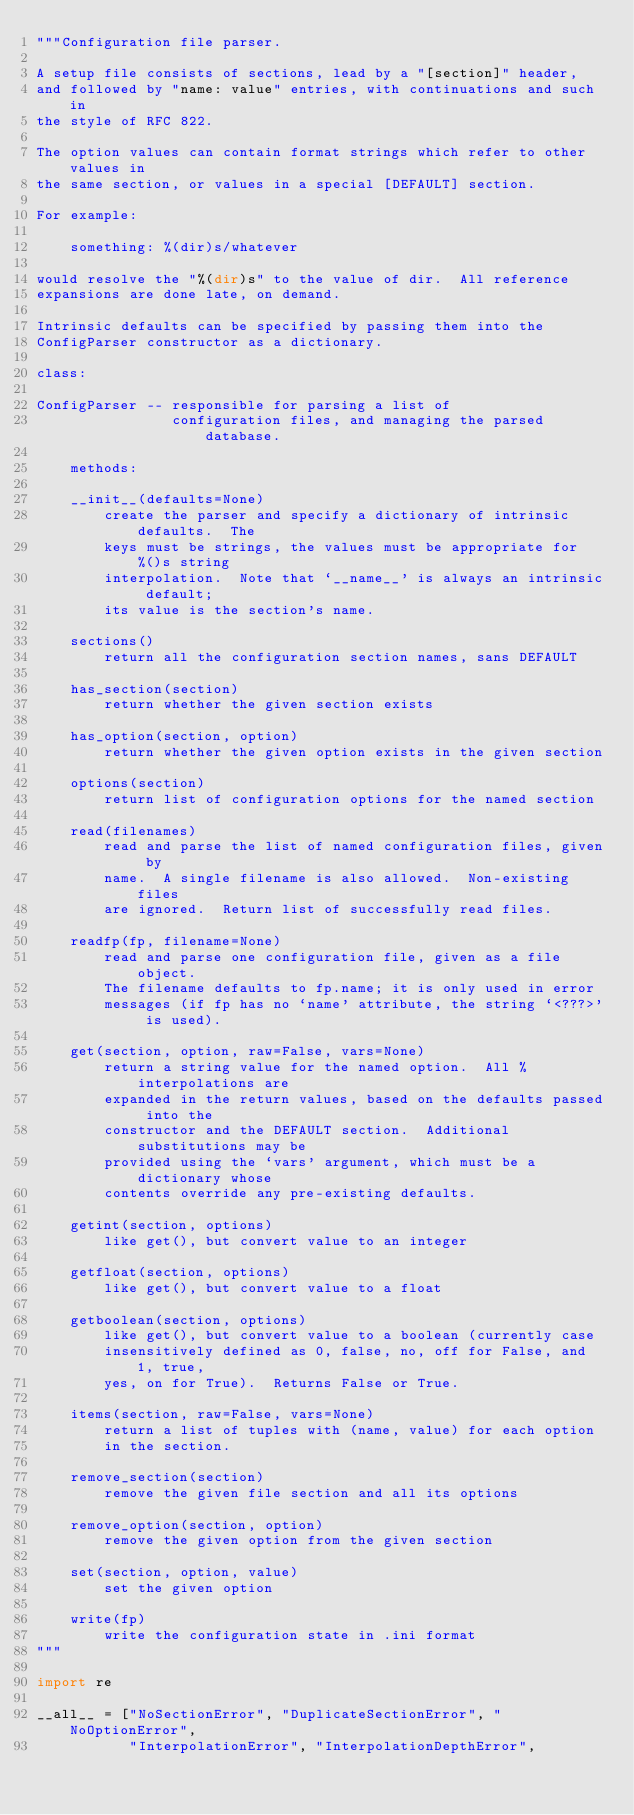Convert code to text. <code><loc_0><loc_0><loc_500><loc_500><_Python_>"""Configuration file parser.

A setup file consists of sections, lead by a "[section]" header,
and followed by "name: value" entries, with continuations and such in
the style of RFC 822.

The option values can contain format strings which refer to other values in
the same section, or values in a special [DEFAULT] section.

For example:

    something: %(dir)s/whatever

would resolve the "%(dir)s" to the value of dir.  All reference
expansions are done late, on demand.

Intrinsic defaults can be specified by passing them into the
ConfigParser constructor as a dictionary.

class:

ConfigParser -- responsible for parsing a list of
                configuration files, and managing the parsed database.

    methods:

    __init__(defaults=None)
        create the parser and specify a dictionary of intrinsic defaults.  The
        keys must be strings, the values must be appropriate for %()s string
        interpolation.  Note that `__name__' is always an intrinsic default;
        its value is the section's name.

    sections()
        return all the configuration section names, sans DEFAULT

    has_section(section)
        return whether the given section exists

    has_option(section, option)
        return whether the given option exists in the given section

    options(section)
        return list of configuration options for the named section

    read(filenames)
        read and parse the list of named configuration files, given by
        name.  A single filename is also allowed.  Non-existing files
        are ignored.  Return list of successfully read files.

    readfp(fp, filename=None)
        read and parse one configuration file, given as a file object.
        The filename defaults to fp.name; it is only used in error
        messages (if fp has no `name' attribute, the string `<???>' is used).

    get(section, option, raw=False, vars=None)
        return a string value for the named option.  All % interpolations are
        expanded in the return values, based on the defaults passed into the
        constructor and the DEFAULT section.  Additional substitutions may be
        provided using the `vars' argument, which must be a dictionary whose
        contents override any pre-existing defaults.

    getint(section, options)
        like get(), but convert value to an integer

    getfloat(section, options)
        like get(), but convert value to a float

    getboolean(section, options)
        like get(), but convert value to a boolean (currently case
        insensitively defined as 0, false, no, off for False, and 1, true,
        yes, on for True).  Returns False or True.

    items(section, raw=False, vars=None)
        return a list of tuples with (name, value) for each option
        in the section.

    remove_section(section)
        remove the given file section and all its options

    remove_option(section, option)
        remove the given option from the given section

    set(section, option, value)
        set the given option

    write(fp)
        write the configuration state in .ini format
"""

import re

__all__ = ["NoSectionError", "DuplicateSectionError", "NoOptionError",
           "InterpolationError", "InterpolationDepthError",</code> 